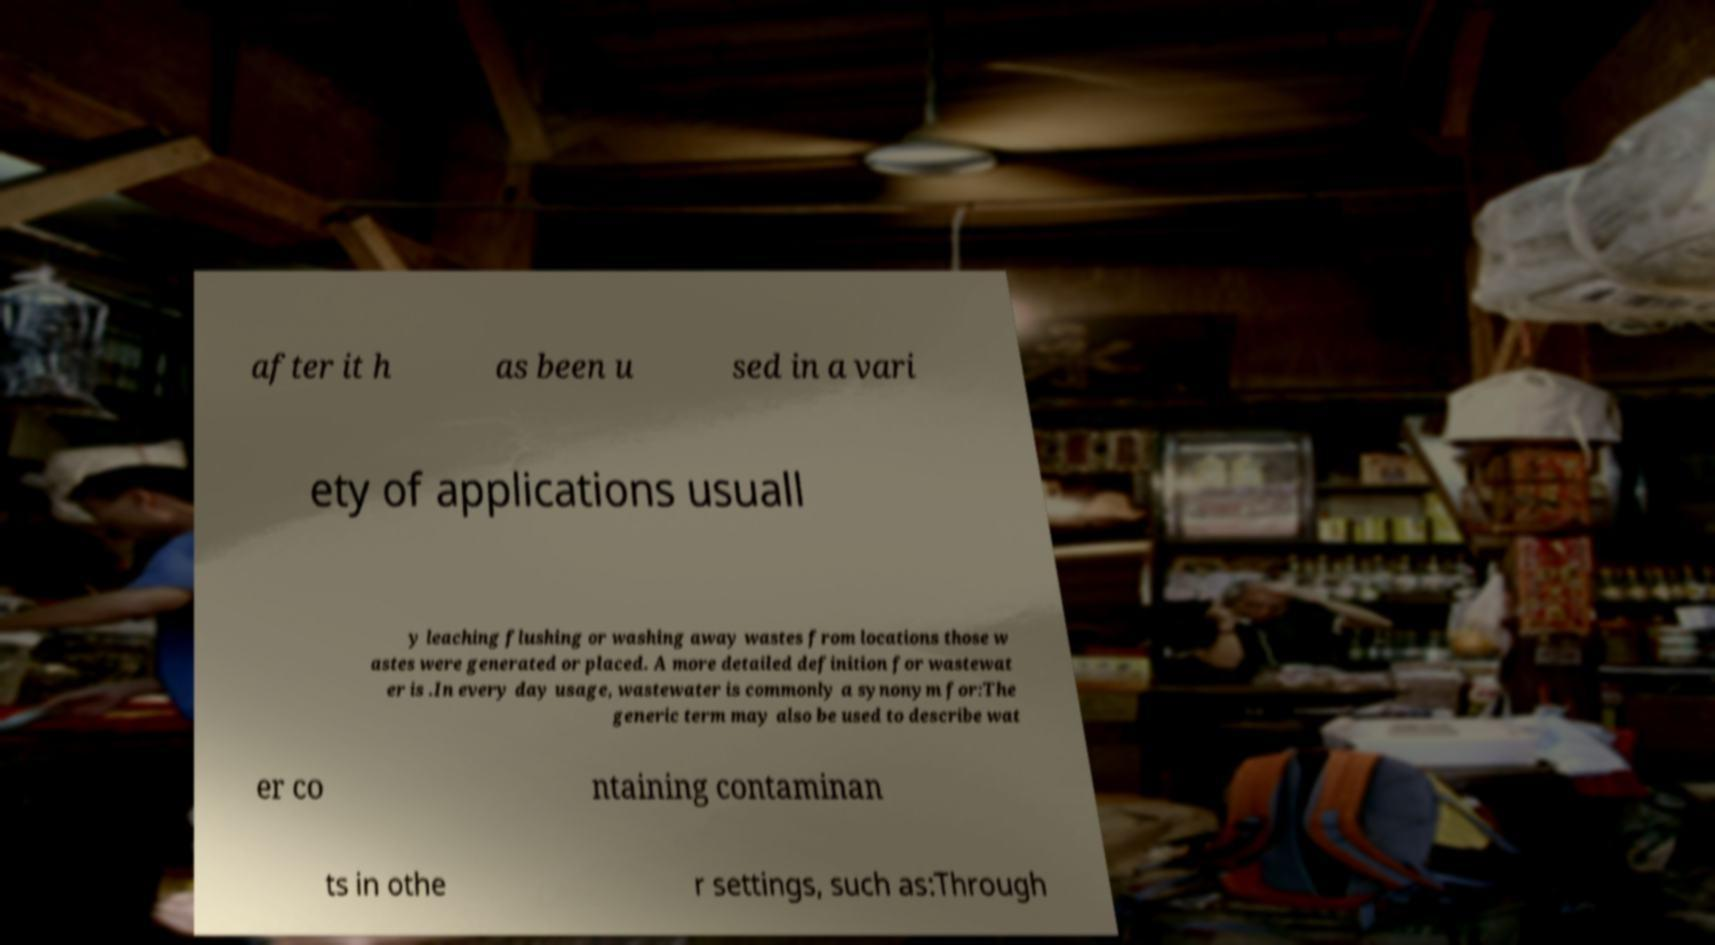For documentation purposes, I need the text within this image transcribed. Could you provide that? after it h as been u sed in a vari ety of applications usuall y leaching flushing or washing away wastes from locations those w astes were generated or placed. A more detailed definition for wastewat er is .In every day usage, wastewater is commonly a synonym for:The generic term may also be used to describe wat er co ntaining contaminan ts in othe r settings, such as:Through 